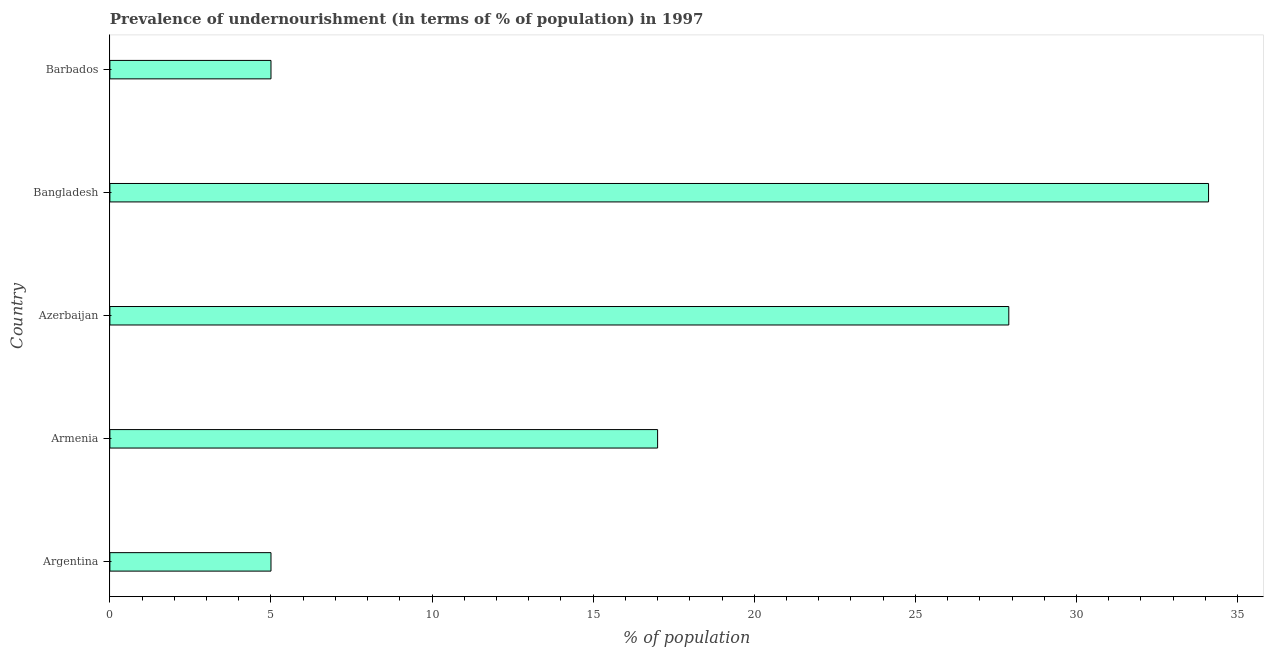Does the graph contain grids?
Provide a succinct answer. No. What is the title of the graph?
Give a very brief answer. Prevalence of undernourishment (in terms of % of population) in 1997. What is the label or title of the X-axis?
Provide a short and direct response. % of population. What is the percentage of undernourished population in Argentina?
Offer a very short reply. 5. Across all countries, what is the maximum percentage of undernourished population?
Offer a terse response. 34.1. Across all countries, what is the minimum percentage of undernourished population?
Keep it short and to the point. 5. What is the sum of the percentage of undernourished population?
Your response must be concise. 89. What is the difference between the percentage of undernourished population in Azerbaijan and Barbados?
Your answer should be compact. 22.9. What is the median percentage of undernourished population?
Your answer should be very brief. 17. In how many countries, is the percentage of undernourished population greater than 19 %?
Ensure brevity in your answer.  2. What is the ratio of the percentage of undernourished population in Argentina to that in Armenia?
Ensure brevity in your answer.  0.29. What is the difference between the highest and the second highest percentage of undernourished population?
Offer a very short reply. 6.2. What is the difference between the highest and the lowest percentage of undernourished population?
Offer a very short reply. 29.1. In how many countries, is the percentage of undernourished population greater than the average percentage of undernourished population taken over all countries?
Provide a short and direct response. 2. Are all the bars in the graph horizontal?
Your response must be concise. Yes. How many countries are there in the graph?
Your response must be concise. 5. Are the values on the major ticks of X-axis written in scientific E-notation?
Provide a succinct answer. No. What is the % of population of Argentina?
Your response must be concise. 5. What is the % of population in Azerbaijan?
Your answer should be compact. 27.9. What is the % of population of Bangladesh?
Give a very brief answer. 34.1. What is the difference between the % of population in Argentina and Armenia?
Provide a short and direct response. -12. What is the difference between the % of population in Argentina and Azerbaijan?
Give a very brief answer. -22.9. What is the difference between the % of population in Argentina and Bangladesh?
Offer a very short reply. -29.1. What is the difference between the % of population in Argentina and Barbados?
Ensure brevity in your answer.  0. What is the difference between the % of population in Armenia and Azerbaijan?
Your answer should be compact. -10.9. What is the difference between the % of population in Armenia and Bangladesh?
Give a very brief answer. -17.1. What is the difference between the % of population in Armenia and Barbados?
Make the answer very short. 12. What is the difference between the % of population in Azerbaijan and Barbados?
Make the answer very short. 22.9. What is the difference between the % of population in Bangladesh and Barbados?
Make the answer very short. 29.1. What is the ratio of the % of population in Argentina to that in Armenia?
Make the answer very short. 0.29. What is the ratio of the % of population in Argentina to that in Azerbaijan?
Ensure brevity in your answer.  0.18. What is the ratio of the % of population in Argentina to that in Bangladesh?
Give a very brief answer. 0.15. What is the ratio of the % of population in Armenia to that in Azerbaijan?
Make the answer very short. 0.61. What is the ratio of the % of population in Armenia to that in Bangladesh?
Provide a short and direct response. 0.5. What is the ratio of the % of population in Azerbaijan to that in Bangladesh?
Make the answer very short. 0.82. What is the ratio of the % of population in Azerbaijan to that in Barbados?
Provide a succinct answer. 5.58. What is the ratio of the % of population in Bangladesh to that in Barbados?
Ensure brevity in your answer.  6.82. 